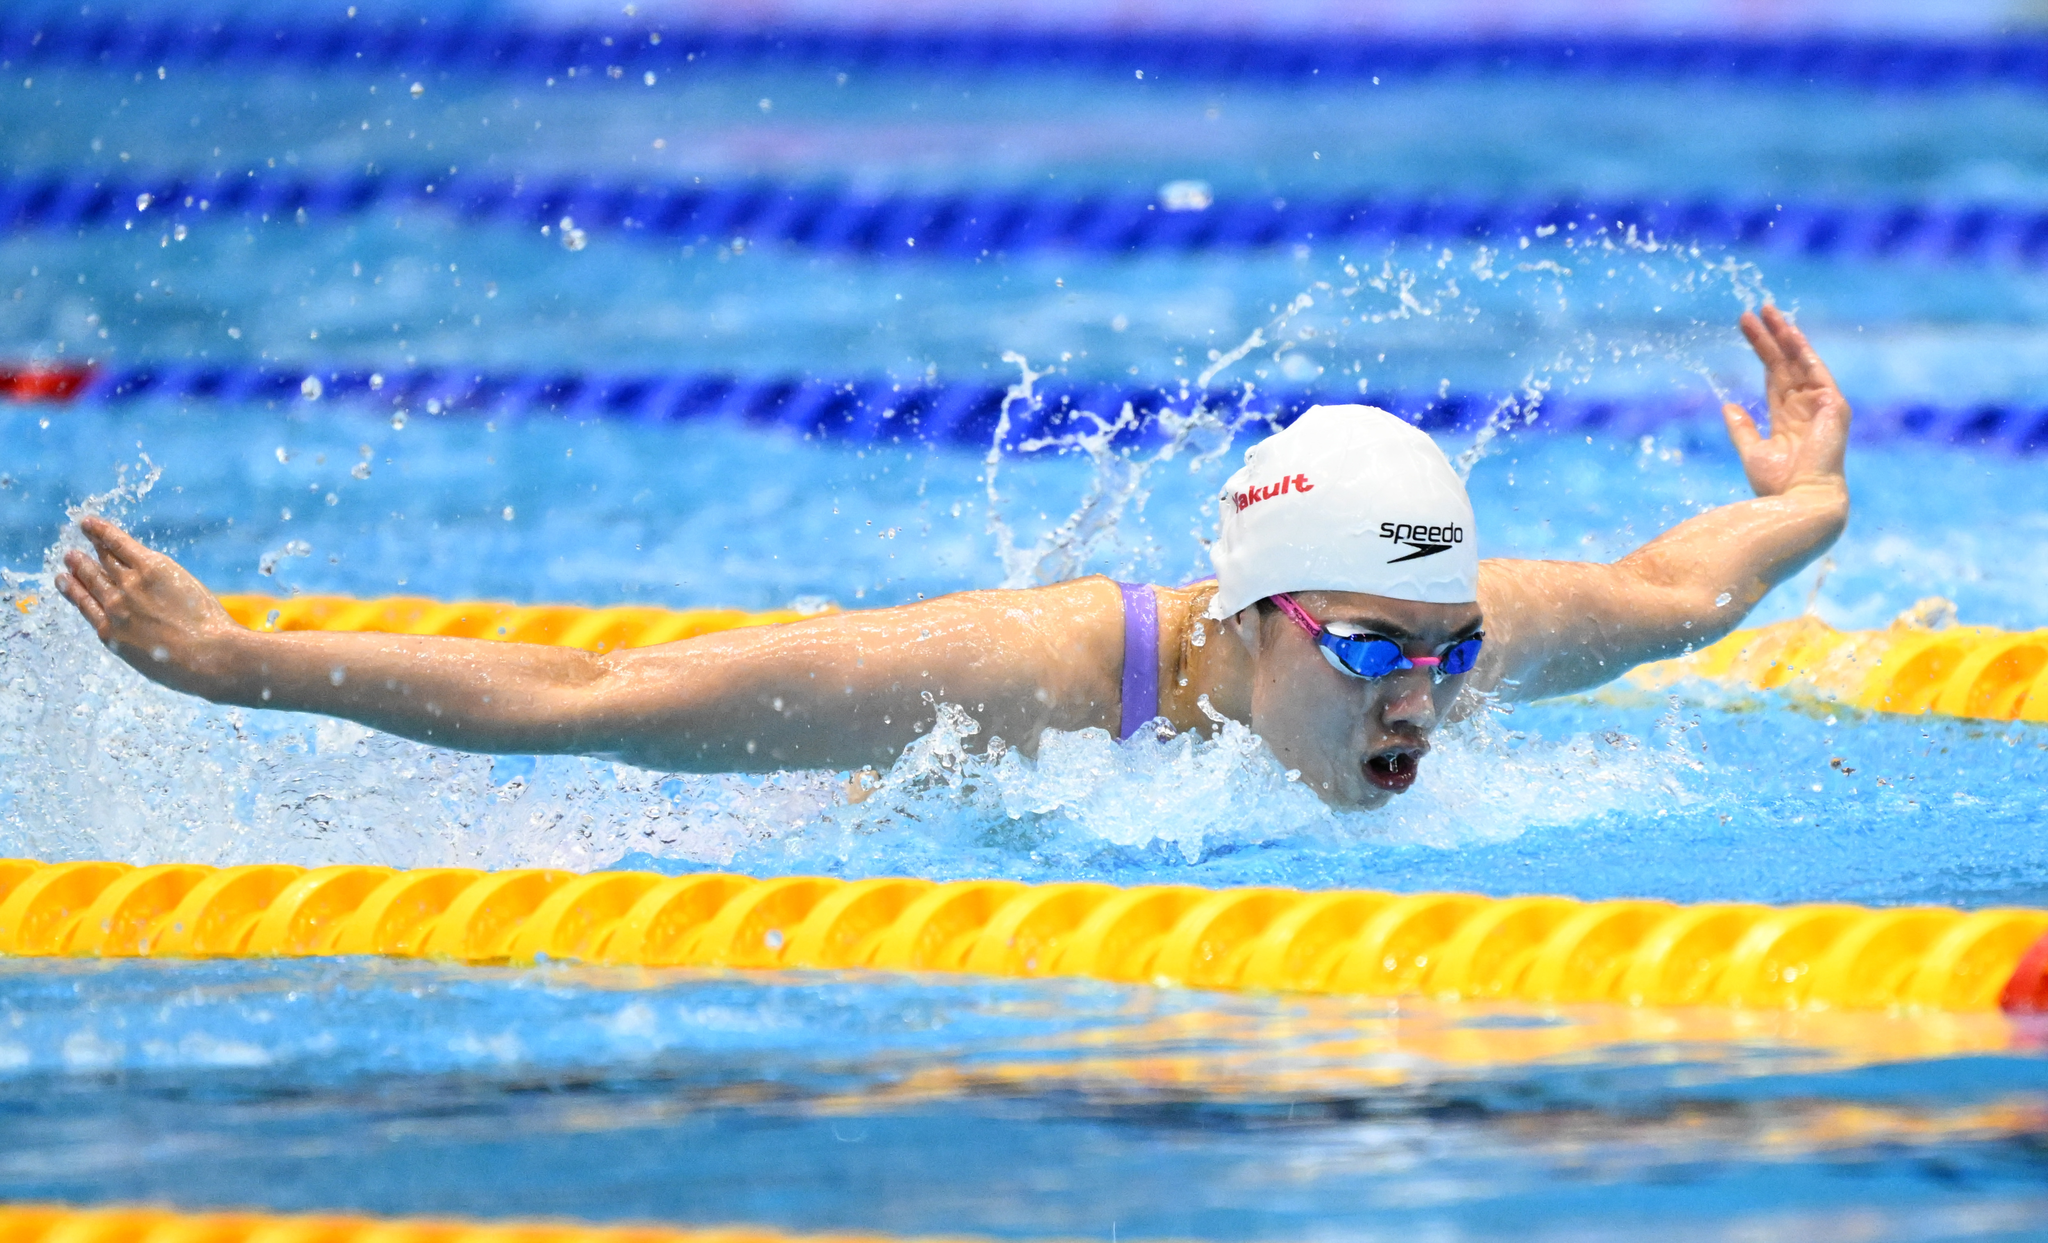what is happening in this picture? This is a picture of a swimmer doing the butterfly stroke. describe what the person is wearing in detail The person is wearing a white and purple swimsuit. The swimsuit has a high neckline and a low back. The person is also wearing a white swim cap and purple goggles. 